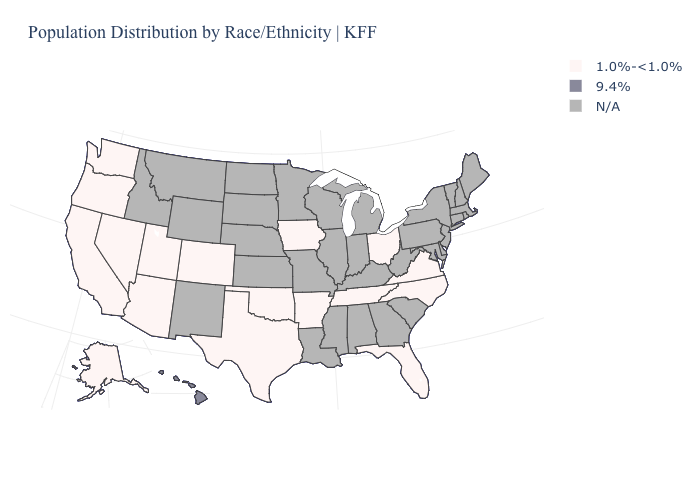What is the value of Vermont?
Be succinct. N/A. Name the states that have a value in the range N/A?
Concise answer only. Alabama, Connecticut, Delaware, Georgia, Idaho, Illinois, Indiana, Kansas, Kentucky, Louisiana, Maine, Maryland, Massachusetts, Michigan, Minnesota, Mississippi, Missouri, Montana, Nebraska, New Hampshire, New Jersey, New Mexico, New York, North Dakota, Pennsylvania, Rhode Island, South Carolina, South Dakota, Vermont, West Virginia, Wisconsin, Wyoming. Among the states that border Arizona , which have the highest value?
Keep it brief. California, Colorado, Nevada, Utah. Does the map have missing data?
Answer briefly. Yes. What is the value of Arizona?
Be succinct. 1.0%-<1.0%. Name the states that have a value in the range N/A?
Quick response, please. Alabama, Connecticut, Delaware, Georgia, Idaho, Illinois, Indiana, Kansas, Kentucky, Louisiana, Maine, Maryland, Massachusetts, Michigan, Minnesota, Mississippi, Missouri, Montana, Nebraska, New Hampshire, New Jersey, New Mexico, New York, North Dakota, Pennsylvania, Rhode Island, South Carolina, South Dakota, Vermont, West Virginia, Wisconsin, Wyoming. What is the value of Colorado?
Give a very brief answer. 1.0%-<1.0%. Which states hav the highest value in the MidWest?
Be succinct. Iowa, Ohio. What is the highest value in states that border Virginia?
Short answer required. 1.0%-<1.0%. 